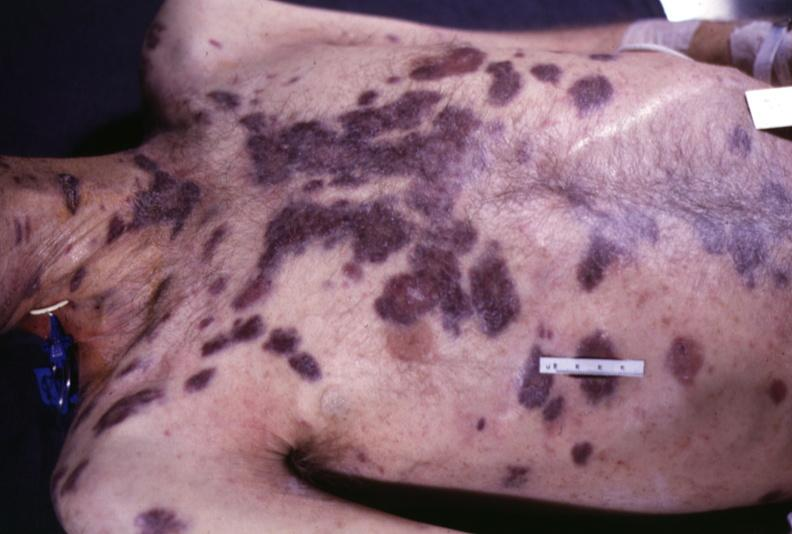does natural color show skin, kaposi 's sarcoma?
Answer the question using a single word or phrase. No 